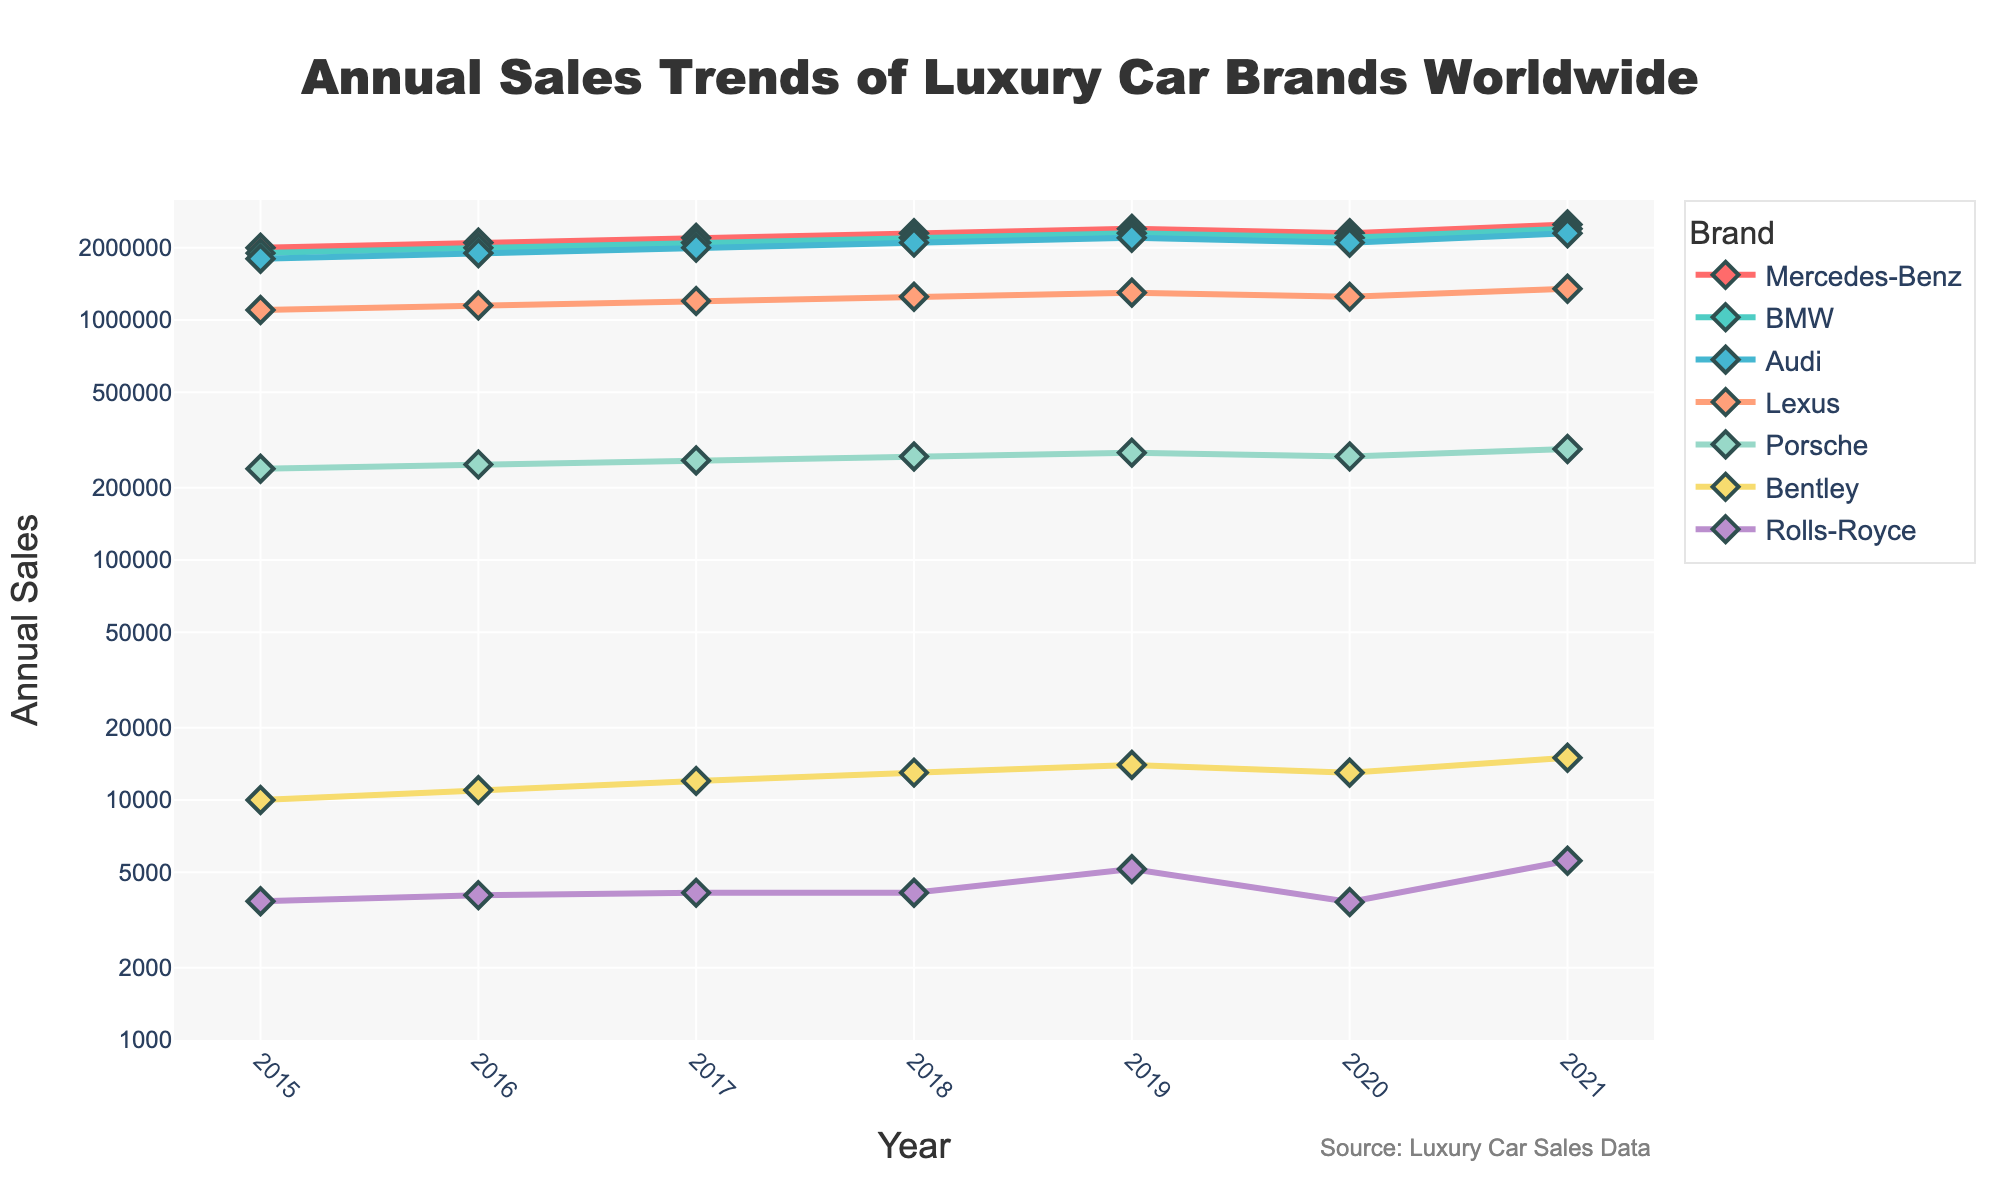What is the title of the graph? The title of the graph is centered at the top with a larger font size and reads "Annual Sales Trends of Luxury Car Brands Worldwide".
Answer: Annual Sales Trends of Luxury Car Brands Worldwide What is the trend for Mercedes-Benz from 2015 to 2021? To determine the trend, look at the line representing Mercedes-Benz. It consistently increases from 2015 to 2019, then slightly drops in 2020, and rises again in 2021.
Answer: Generally increasing with a dip in 2020 In which year did BMW have the highest sales, and what was the value? Identify the highest point on the BMW line. In 2021, BMW had the highest sales at about 2,400,000 units.
Answer: 2021, 2,400,000 units Compare the sales of Audi in 2018 and Lexus in 2020. Which brand sold more cars and by how much? Look at the sales values for Audi in 2018 and Lexus in 2020. Audi sold approximately 2,100,000 units in 2018, and Lexus sold around 1,250,000 units in 2020. Audi sold more by (2,100,000 - 1,250,000) = 850,000 units.
Answer: Audi, 850,000 units Which brand had the lowest sales overall, and what was the lowest sales number recorded? Examine the y-axis and find the lowest point on any of the lines. Rolls-Royce had the lowest overall sales in 2020, recording 3,756 units.
Answer: Rolls-Royce, 3,756 units What can you infer about Porsche's sales trend from 2015 to 2021? The Porsche line shows a gradual increase from 2015 to 2019, a dip in 2020, and then a rise again in 2021. This indicates a generally stable increasing trend with a slight drop in 2020.
Answer: Stable increasing with a drop in 2020 How did the COVID-19 pandemic in 2020 affect the sales of the listed brands? By examining the year 2020 for each brand, most brands show a decline in sales that year: Mercedes-Benz, BMW, Audi, Lexus, Porsche, and Rolls-Royce all have lower values compared to 2019.
Answer: Sales declined for most brands What is the difference in sales between the highest and lowest selling brands in 2021? Compare the highest point in 2021 (Mercedes-Benz with 2,500,000 units) to the lowest point (Rolls-Royce with 5,586 units). The difference is (2,500,000 - 5,586) = 2,494,414 units.
Answer: 2,494,414 units Which brand's sales data shows the steepest increase from 2019 to 2021? Look at the slope of the lines between 2019 to 2021. Rolls-Royce shows the steepest increase, going from 5,152 in 2019 to 5,586 in 2021, but since it's a log scale, visually, Mercedes-Benz and other major brands show substantial increases too. Based on visual steepness, it's close among top brands, but Rolls-Royce has the higher rate proportionally.
Answer: Rolls-Royce 